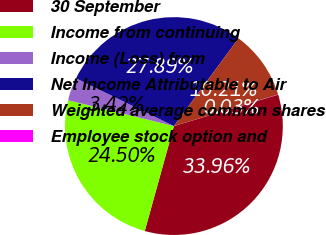Convert chart. <chart><loc_0><loc_0><loc_500><loc_500><pie_chart><fcel>30 September<fcel>Income from continuing<fcel>Income (Loss) from<fcel>Net Income Attributable to Air<fcel>Weighted average common shares<fcel>Employee stock option and<nl><fcel>33.96%<fcel>24.5%<fcel>3.42%<fcel>27.89%<fcel>10.21%<fcel>0.03%<nl></chart> 